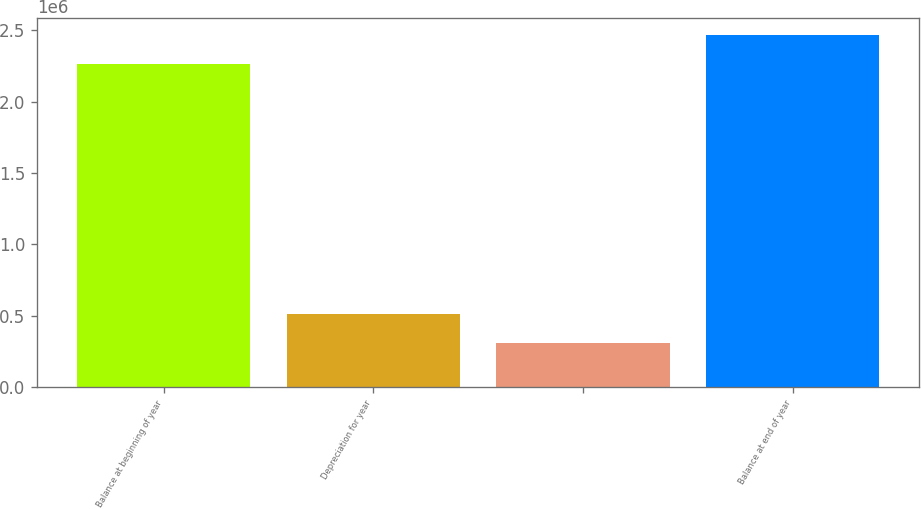<chart> <loc_0><loc_0><loc_500><loc_500><bar_chart><fcel>Balance at beginning of year<fcel>Depreciation for year<fcel>Unnamed: 2<fcel>Balance at end of year<nl><fcel>2.26469e+06<fcel>510445<fcel>311593<fcel>2.46355e+06<nl></chart> 